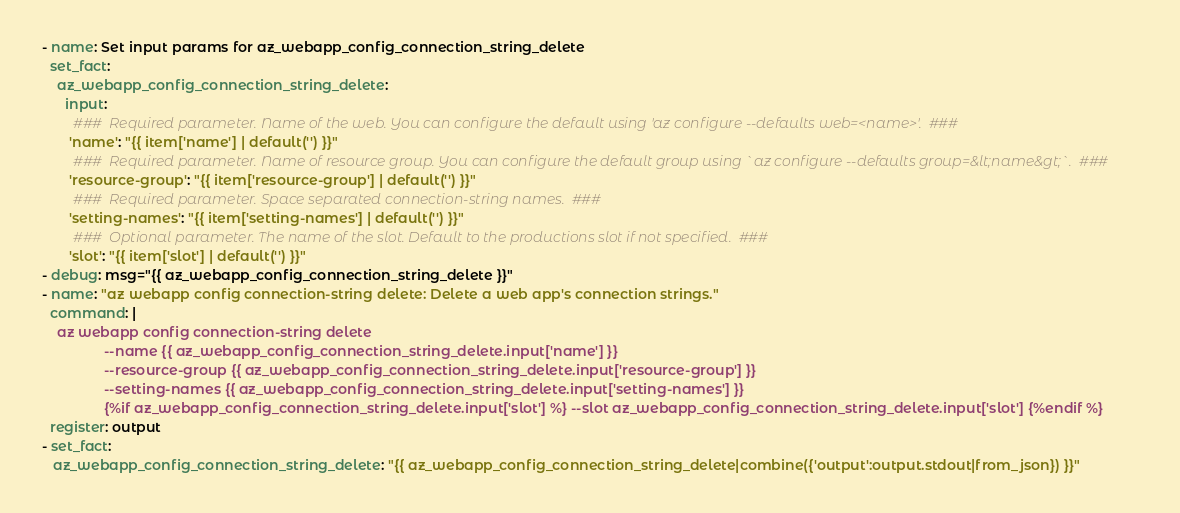<code> <loc_0><loc_0><loc_500><loc_500><_YAML_>

 - name: Set input params for az_webapp_config_connection_string_delete
   set_fact: 
     az_webapp_config_connection_string_delete:
       input: 
         ###  Required parameter. Name of the web. You can configure the default using 'az configure --defaults web=<name>'.  ### 
        'name': "{{ item['name'] | default('') }}" 
         ###  Required parameter. Name of resource group. You can configure the default group using `az configure --defaults group=&lt;name&gt;`.  ### 
        'resource-group': "{{ item['resource-group'] | default('') }}" 
         ###  Required parameter. Space separated connection-string names.  ### 
        'setting-names': "{{ item['setting-names'] | default('') }}" 
         ###  Optional parameter. The name of the slot. Default to the productions slot if not specified.  ### 
        'slot': "{{ item['slot'] | default('') }}" 
 - debug: msg="{{ az_webapp_config_connection_string_delete }}"          
 - name: "az webapp config connection-string delete: Delete a web app's connection strings." 
   command: |                                      
     az webapp config connection-string delete                            
                 --name {{ az_webapp_config_connection_string_delete.input['name'] }} 
                 --resource-group {{ az_webapp_config_connection_string_delete.input['resource-group'] }} 
                 --setting-names {{ az_webapp_config_connection_string_delete.input['setting-names'] }} 
                 {%if az_webapp_config_connection_string_delete.input['slot'] %} --slot az_webapp_config_connection_string_delete.input['slot'] {%endif %} 
   register: output  
 - set_fact: 
    az_webapp_config_connection_string_delete: "{{ az_webapp_config_connection_string_delete|combine({'output':output.stdout|from_json}) }}"  </code> 